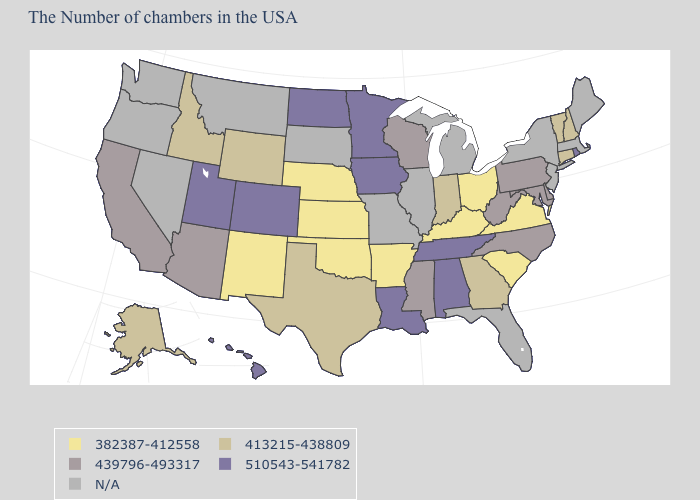What is the lowest value in the West?
Write a very short answer. 382387-412558. Does the first symbol in the legend represent the smallest category?
Keep it brief. Yes. What is the value of Nevada?
Keep it brief. N/A. What is the value of Alaska?
Keep it brief. 413215-438809. What is the highest value in the West ?
Quick response, please. 510543-541782. What is the value of Mississippi?
Concise answer only. 439796-493317. Does the map have missing data?
Be succinct. Yes. Does Tennessee have the highest value in the USA?
Answer briefly. Yes. Which states have the highest value in the USA?
Keep it brief. Rhode Island, Alabama, Tennessee, Louisiana, Minnesota, Iowa, North Dakota, Colorado, Utah, Hawaii. What is the value of Wyoming?
Be succinct. 413215-438809. Which states have the lowest value in the MidWest?
Quick response, please. Ohio, Kansas, Nebraska. Among the states that border Maryland , which have the highest value?
Be succinct. Delaware, Pennsylvania, West Virginia. Name the states that have a value in the range N/A?
Quick response, please. Maine, Massachusetts, New York, New Jersey, Florida, Michigan, Illinois, Missouri, South Dakota, Montana, Nevada, Washington, Oregon. What is the lowest value in states that border Maryland?
Keep it brief. 382387-412558. 